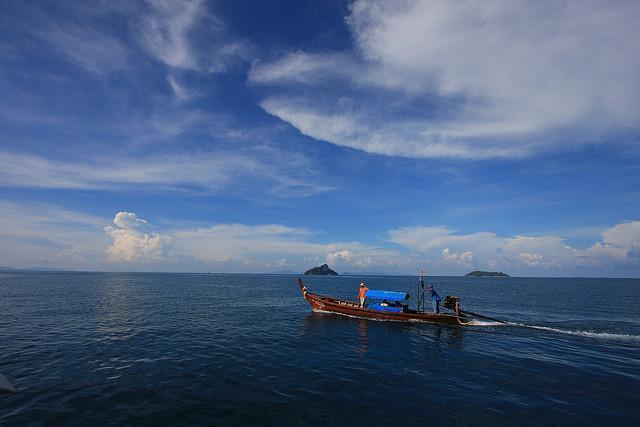How many islands are visible?
Give a very brief answer. 2. How many boats are there?
Give a very brief answer. 1. How many boats are in the water?
Give a very brief answer. 1. How many glass cups have water in them?
Give a very brief answer. 0. 